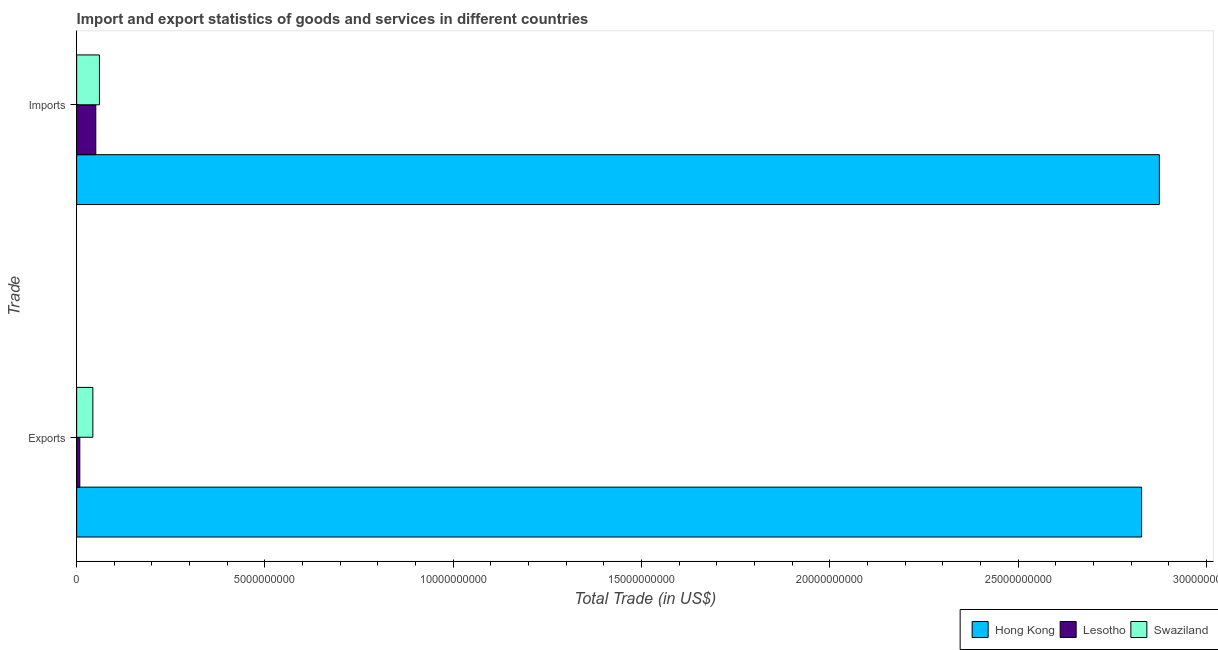How many groups of bars are there?
Your answer should be compact. 2. Are the number of bars per tick equal to the number of legend labels?
Keep it short and to the point. Yes. Are the number of bars on each tick of the Y-axis equal?
Ensure brevity in your answer.  Yes. How many bars are there on the 2nd tick from the bottom?
Provide a succinct answer. 3. What is the label of the 1st group of bars from the top?
Provide a succinct answer. Imports. What is the imports of goods and services in Lesotho?
Provide a short and direct response. 5.08e+08. Across all countries, what is the maximum imports of goods and services?
Your response must be concise. 2.87e+1. Across all countries, what is the minimum imports of goods and services?
Keep it short and to the point. 5.08e+08. In which country was the export of goods and services maximum?
Provide a succinct answer. Hong Kong. In which country was the imports of goods and services minimum?
Make the answer very short. Lesotho. What is the total imports of goods and services in the graph?
Your response must be concise. 2.99e+1. What is the difference between the export of goods and services in Lesotho and that in Swaziland?
Provide a short and direct response. -3.46e+08. What is the difference between the export of goods and services in Hong Kong and the imports of goods and services in Lesotho?
Offer a very short reply. 2.78e+1. What is the average export of goods and services per country?
Keep it short and to the point. 9.60e+09. What is the difference between the imports of goods and services and export of goods and services in Hong Kong?
Keep it short and to the point. 4.71e+08. What is the ratio of the imports of goods and services in Swaziland to that in Hong Kong?
Give a very brief answer. 0.02. Is the imports of goods and services in Lesotho less than that in Hong Kong?
Your answer should be very brief. Yes. In how many countries, is the export of goods and services greater than the average export of goods and services taken over all countries?
Your answer should be very brief. 1. What does the 3rd bar from the top in Imports represents?
Make the answer very short. Hong Kong. What does the 3rd bar from the bottom in Exports represents?
Make the answer very short. Swaziland. Are all the bars in the graph horizontal?
Your response must be concise. Yes. Does the graph contain any zero values?
Give a very brief answer. No. Does the graph contain grids?
Ensure brevity in your answer.  No. How are the legend labels stacked?
Your answer should be compact. Horizontal. What is the title of the graph?
Your response must be concise. Import and export statistics of goods and services in different countries. What is the label or title of the X-axis?
Ensure brevity in your answer.  Total Trade (in US$). What is the label or title of the Y-axis?
Make the answer very short. Trade. What is the Total Trade (in US$) in Hong Kong in Exports?
Your response must be concise. 2.83e+1. What is the Total Trade (in US$) in Lesotho in Exports?
Make the answer very short. 8.38e+07. What is the Total Trade (in US$) of Swaziland in Exports?
Make the answer very short. 4.30e+08. What is the Total Trade (in US$) of Hong Kong in Imports?
Ensure brevity in your answer.  2.87e+1. What is the Total Trade (in US$) in Lesotho in Imports?
Your answer should be very brief. 5.08e+08. What is the Total Trade (in US$) in Swaziland in Imports?
Your response must be concise. 6.05e+08. Across all Trade, what is the maximum Total Trade (in US$) of Hong Kong?
Provide a short and direct response. 2.87e+1. Across all Trade, what is the maximum Total Trade (in US$) in Lesotho?
Offer a terse response. 5.08e+08. Across all Trade, what is the maximum Total Trade (in US$) in Swaziland?
Keep it short and to the point. 6.05e+08. Across all Trade, what is the minimum Total Trade (in US$) in Hong Kong?
Keep it short and to the point. 2.83e+1. Across all Trade, what is the minimum Total Trade (in US$) in Lesotho?
Ensure brevity in your answer.  8.38e+07. Across all Trade, what is the minimum Total Trade (in US$) of Swaziland?
Make the answer very short. 4.30e+08. What is the total Total Trade (in US$) of Hong Kong in the graph?
Offer a very short reply. 5.70e+1. What is the total Total Trade (in US$) of Lesotho in the graph?
Ensure brevity in your answer.  5.92e+08. What is the total Total Trade (in US$) of Swaziland in the graph?
Give a very brief answer. 1.03e+09. What is the difference between the Total Trade (in US$) in Hong Kong in Exports and that in Imports?
Keep it short and to the point. -4.71e+08. What is the difference between the Total Trade (in US$) in Lesotho in Exports and that in Imports?
Give a very brief answer. -4.24e+08. What is the difference between the Total Trade (in US$) of Swaziland in Exports and that in Imports?
Your answer should be very brief. -1.75e+08. What is the difference between the Total Trade (in US$) in Hong Kong in Exports and the Total Trade (in US$) in Lesotho in Imports?
Keep it short and to the point. 2.78e+1. What is the difference between the Total Trade (in US$) of Hong Kong in Exports and the Total Trade (in US$) of Swaziland in Imports?
Make the answer very short. 2.77e+1. What is the difference between the Total Trade (in US$) of Lesotho in Exports and the Total Trade (in US$) of Swaziland in Imports?
Offer a very short reply. -5.21e+08. What is the average Total Trade (in US$) in Hong Kong per Trade?
Your response must be concise. 2.85e+1. What is the average Total Trade (in US$) of Lesotho per Trade?
Your response must be concise. 2.96e+08. What is the average Total Trade (in US$) in Swaziland per Trade?
Your answer should be very brief. 5.17e+08. What is the difference between the Total Trade (in US$) of Hong Kong and Total Trade (in US$) of Lesotho in Exports?
Make the answer very short. 2.82e+1. What is the difference between the Total Trade (in US$) in Hong Kong and Total Trade (in US$) in Swaziland in Exports?
Provide a short and direct response. 2.78e+1. What is the difference between the Total Trade (in US$) in Lesotho and Total Trade (in US$) in Swaziland in Exports?
Make the answer very short. -3.46e+08. What is the difference between the Total Trade (in US$) in Hong Kong and Total Trade (in US$) in Lesotho in Imports?
Keep it short and to the point. 2.82e+1. What is the difference between the Total Trade (in US$) of Hong Kong and Total Trade (in US$) of Swaziland in Imports?
Provide a short and direct response. 2.81e+1. What is the difference between the Total Trade (in US$) of Lesotho and Total Trade (in US$) of Swaziland in Imports?
Keep it short and to the point. -9.68e+07. What is the ratio of the Total Trade (in US$) in Hong Kong in Exports to that in Imports?
Make the answer very short. 0.98. What is the ratio of the Total Trade (in US$) in Lesotho in Exports to that in Imports?
Make the answer very short. 0.16. What is the ratio of the Total Trade (in US$) of Swaziland in Exports to that in Imports?
Make the answer very short. 0.71. What is the difference between the highest and the second highest Total Trade (in US$) in Hong Kong?
Keep it short and to the point. 4.71e+08. What is the difference between the highest and the second highest Total Trade (in US$) in Lesotho?
Offer a very short reply. 4.24e+08. What is the difference between the highest and the second highest Total Trade (in US$) of Swaziland?
Your answer should be very brief. 1.75e+08. What is the difference between the highest and the lowest Total Trade (in US$) of Hong Kong?
Provide a short and direct response. 4.71e+08. What is the difference between the highest and the lowest Total Trade (in US$) of Lesotho?
Your answer should be very brief. 4.24e+08. What is the difference between the highest and the lowest Total Trade (in US$) in Swaziland?
Your answer should be compact. 1.75e+08. 